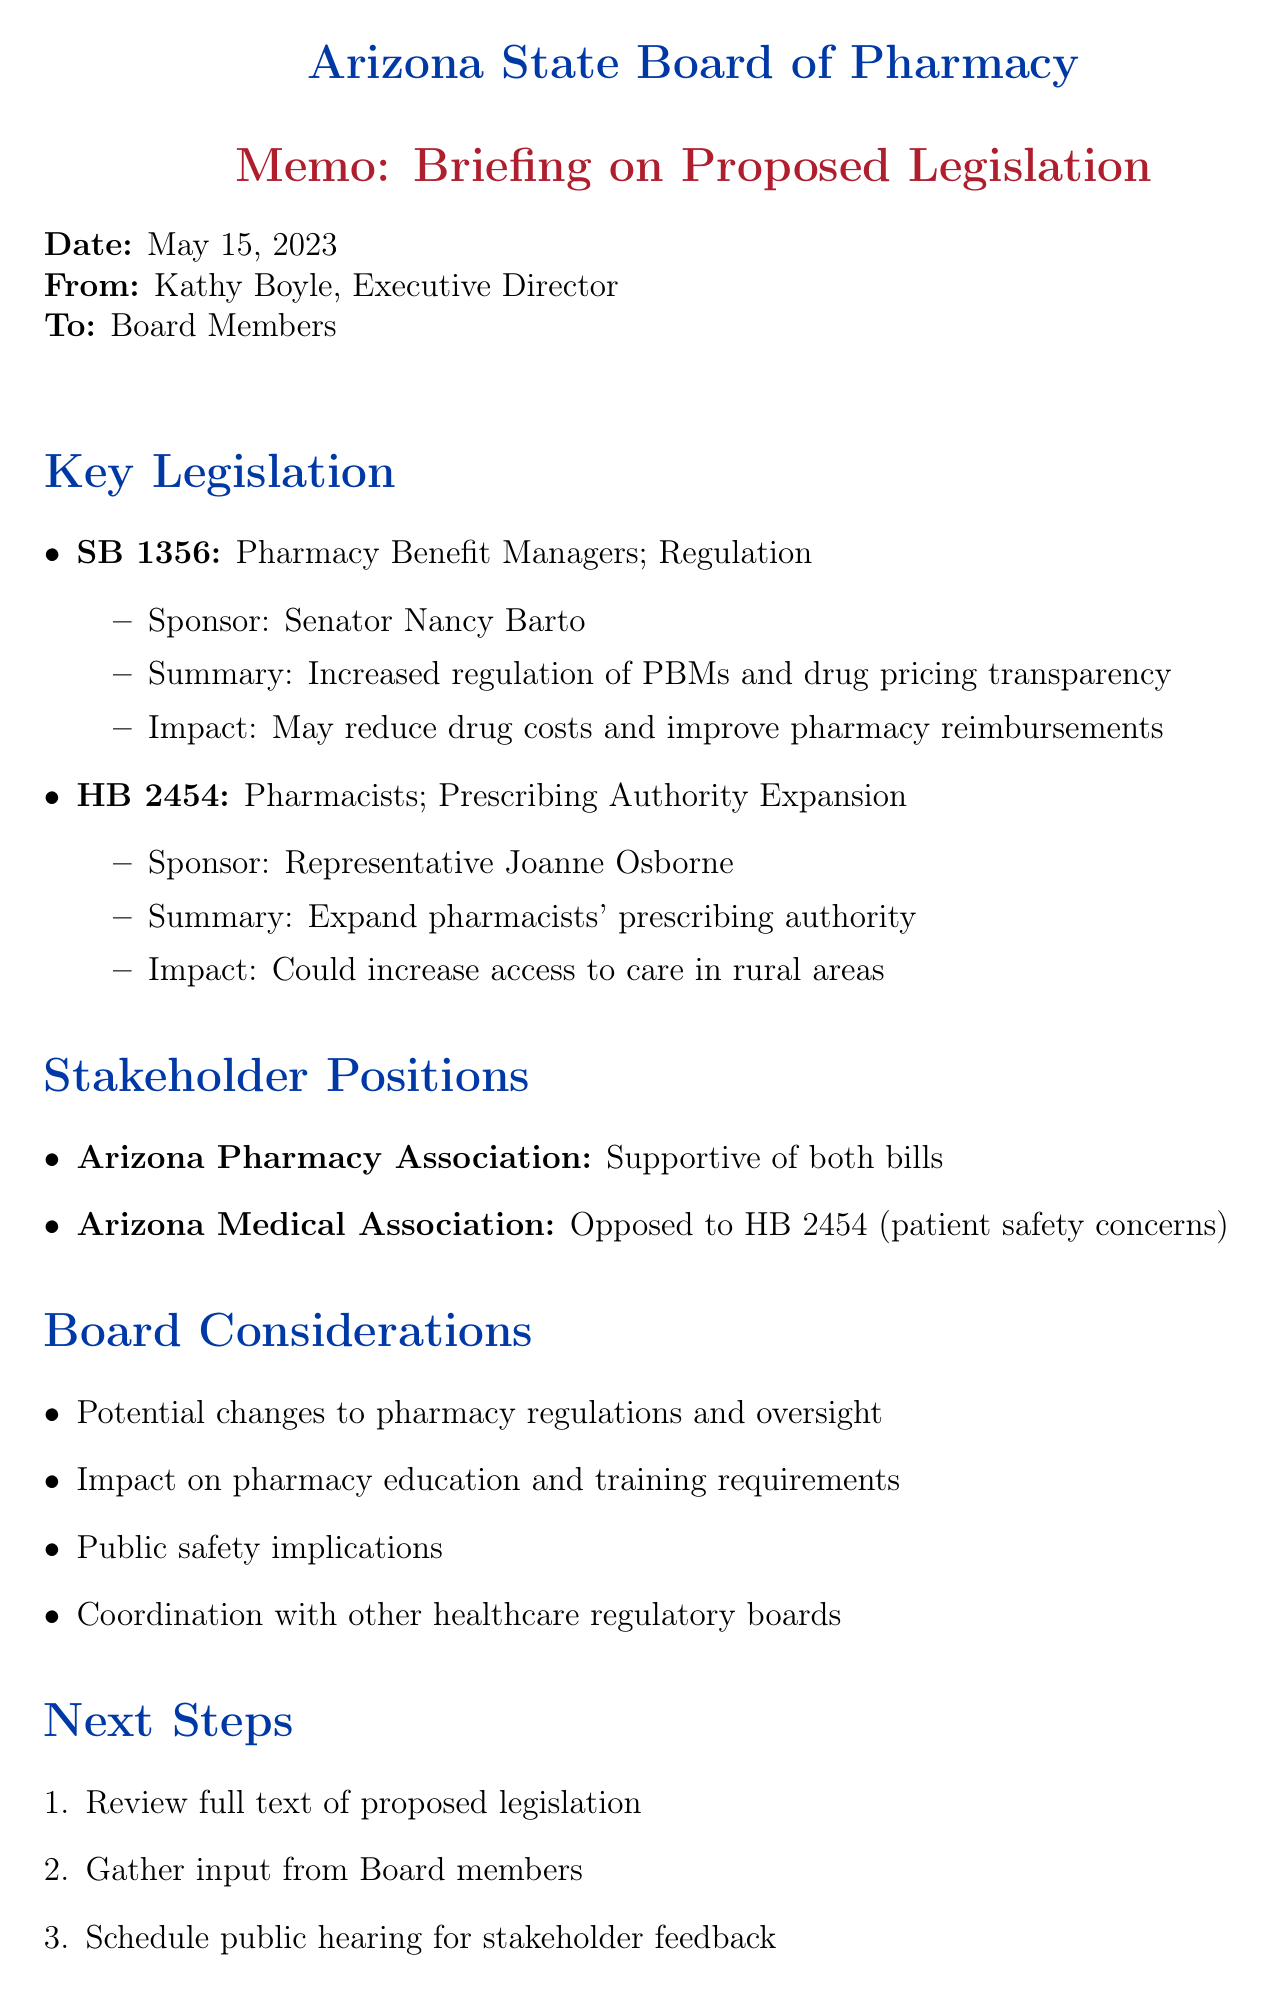What is the date of the memo? The date of the memo can be found in the header section where it states the release date.
Answer: May 15, 2023 Who is the sponsor of SB 1356? The sponsor of SB 1356 is mentioned under the key legislation section.
Answer: Senator Nancy Barto What is the stance of the Arizona Pharmacy Association on the proposed legislation? The Arizona Pharmacy Association's stance is included in the stakeholder positions section.
Answer: Supportive of both bills What are the potential impacts of HB 2454? The impacts of HB 2454 are listed in the summary of the key legislation section.
Answer: Could increase access to care, especially in rural areas Which board consideration relates to public safety? Public safety implications are explicitly mentioned as one of the board considerations.
Answer: Public safety implications What is the next step after gathering input from Board members? The next step is outlined in the 'Next Steps' section of the memo.
Answer: Schedule public hearing for stakeholder feedback Who should be contacted for questions? The contact for questions is specified in the last section of the document.
Answer: Michael Thompson What bill proposes increased regulation of pharmacy benefit managers? The title and details of the bill proposing this regulation are summarized in the key legislation section.
Answer: SB 1356 